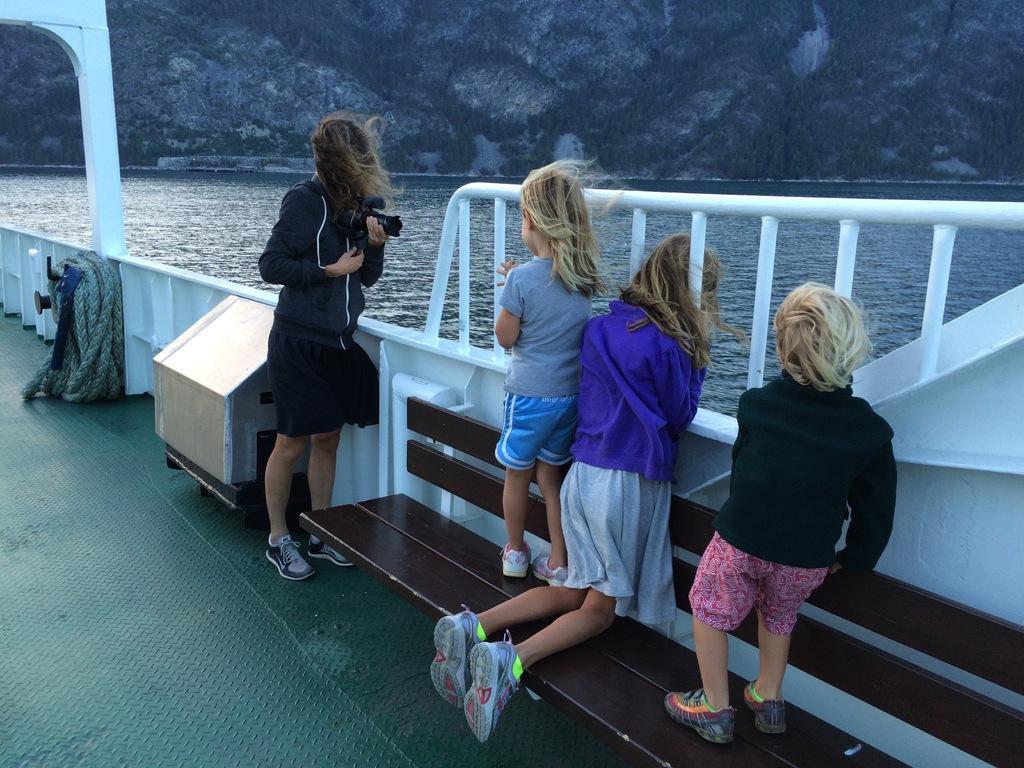Describe this image in one or two sentences. In this image I can see few people and they are wearing different color dress. One person is holding camera. They are inside the white boat. I can see a rope,water and mountains. 